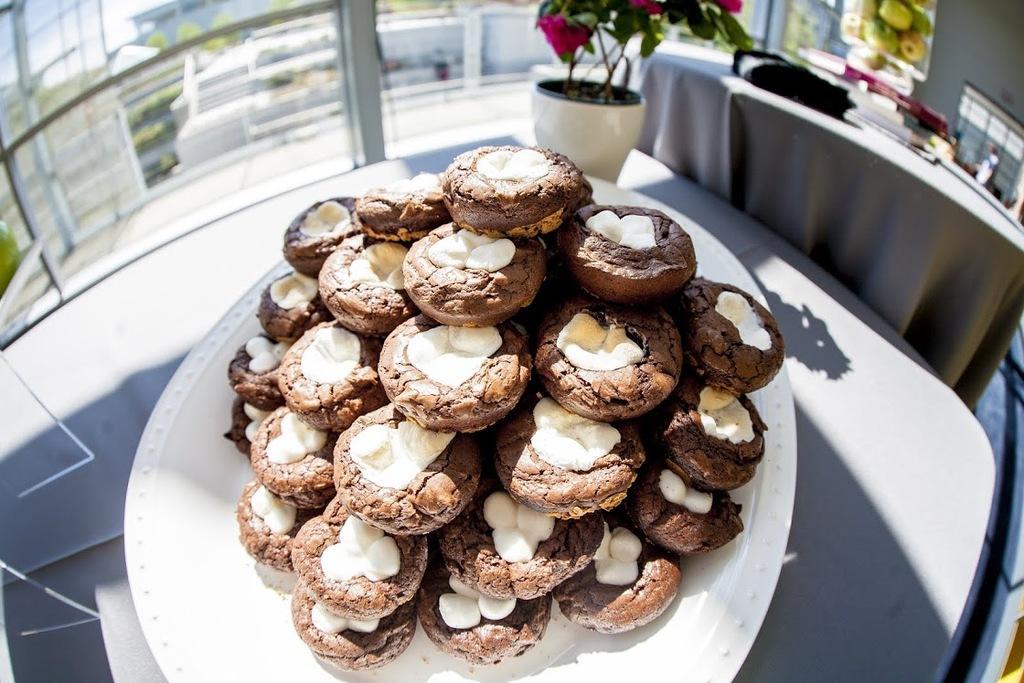Could you give a brief overview of what you see in this image? In this image we can see a serving plate which has cookies placed in rows on it, houseplant, picture to the wall and tables. 